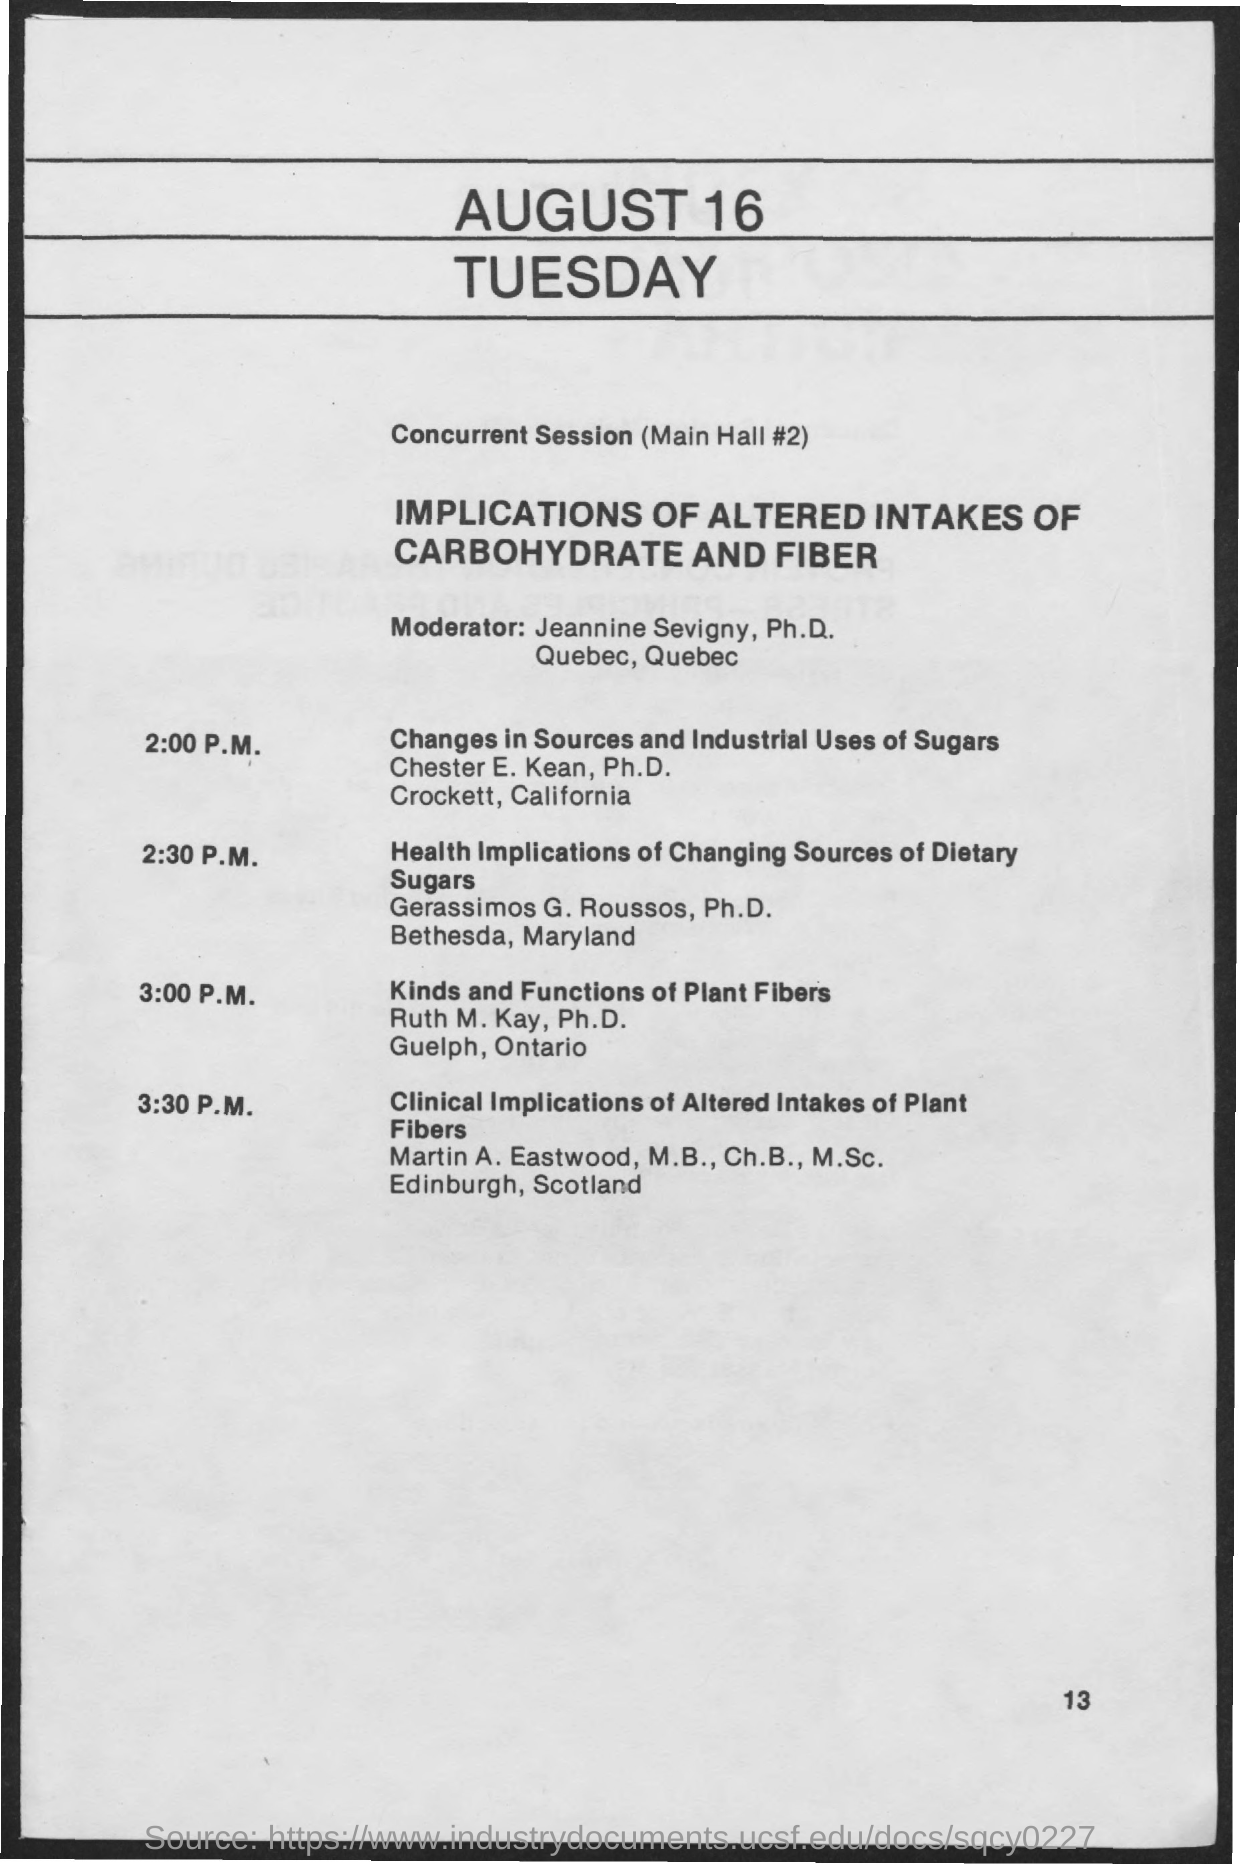What is the date on the document?
Your response must be concise. August 16. 